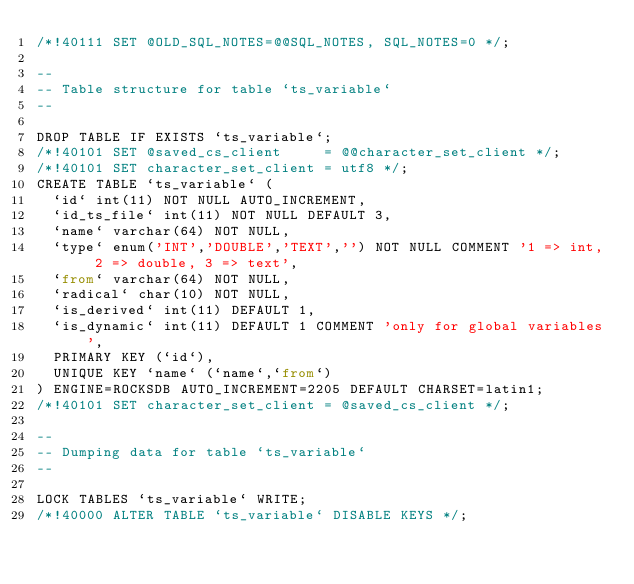<code> <loc_0><loc_0><loc_500><loc_500><_SQL_>/*!40111 SET @OLD_SQL_NOTES=@@SQL_NOTES, SQL_NOTES=0 */;

--
-- Table structure for table `ts_variable`
--

DROP TABLE IF EXISTS `ts_variable`;
/*!40101 SET @saved_cs_client     = @@character_set_client */;
/*!40101 SET character_set_client = utf8 */;
CREATE TABLE `ts_variable` (
  `id` int(11) NOT NULL AUTO_INCREMENT,
  `id_ts_file` int(11) NOT NULL DEFAULT 3,
  `name` varchar(64) NOT NULL,
  `type` enum('INT','DOUBLE','TEXT','') NOT NULL COMMENT '1 => int, 2 => double, 3 => text',
  `from` varchar(64) NOT NULL,
  `radical` char(10) NOT NULL,
  `is_derived` int(11) DEFAULT 1,
  `is_dynamic` int(11) DEFAULT 1 COMMENT 'only for global variables',
  PRIMARY KEY (`id`),
  UNIQUE KEY `name` (`name`,`from`)
) ENGINE=ROCKSDB AUTO_INCREMENT=2205 DEFAULT CHARSET=latin1;
/*!40101 SET character_set_client = @saved_cs_client */;

--
-- Dumping data for table `ts_variable`
--

LOCK TABLES `ts_variable` WRITE;
/*!40000 ALTER TABLE `ts_variable` DISABLE KEYS */;</code> 